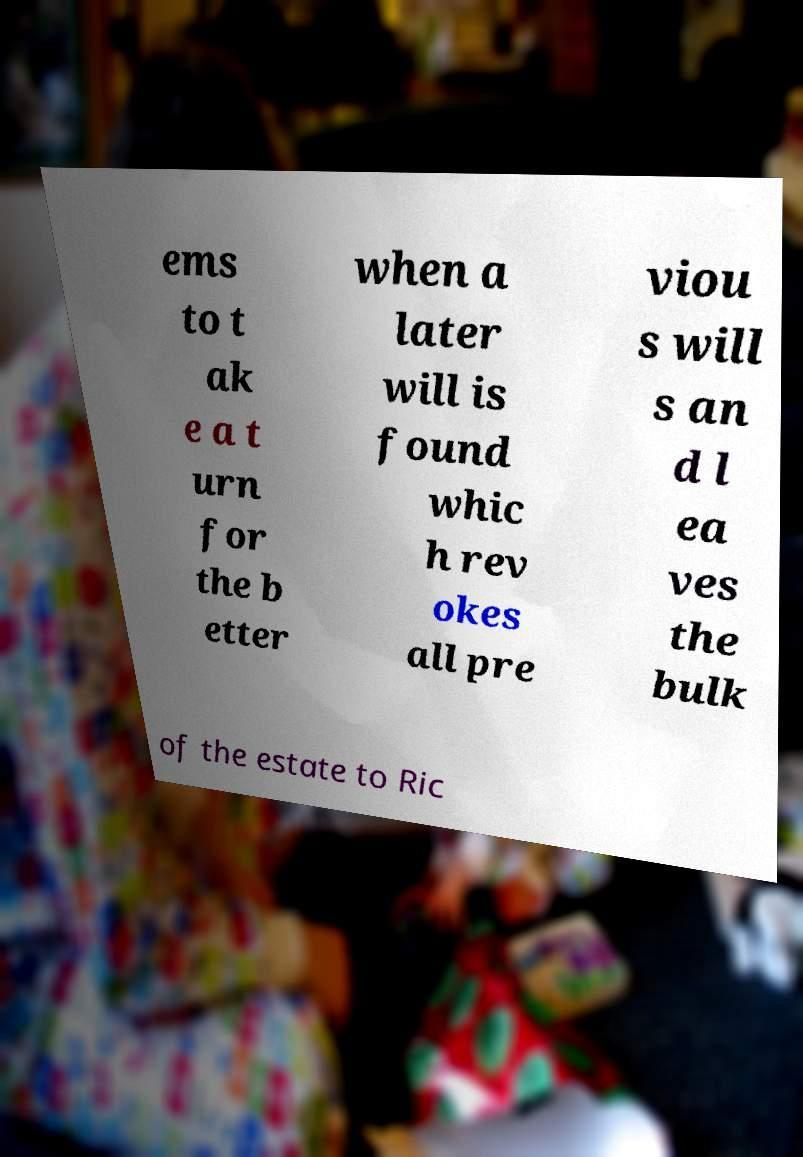There's text embedded in this image that I need extracted. Can you transcribe it verbatim? ems to t ak e a t urn for the b etter when a later will is found whic h rev okes all pre viou s will s an d l ea ves the bulk of the estate to Ric 